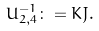<formula> <loc_0><loc_0><loc_500><loc_500>U _ { 2 , 4 } ^ { - 1 } \colon = K J .</formula> 